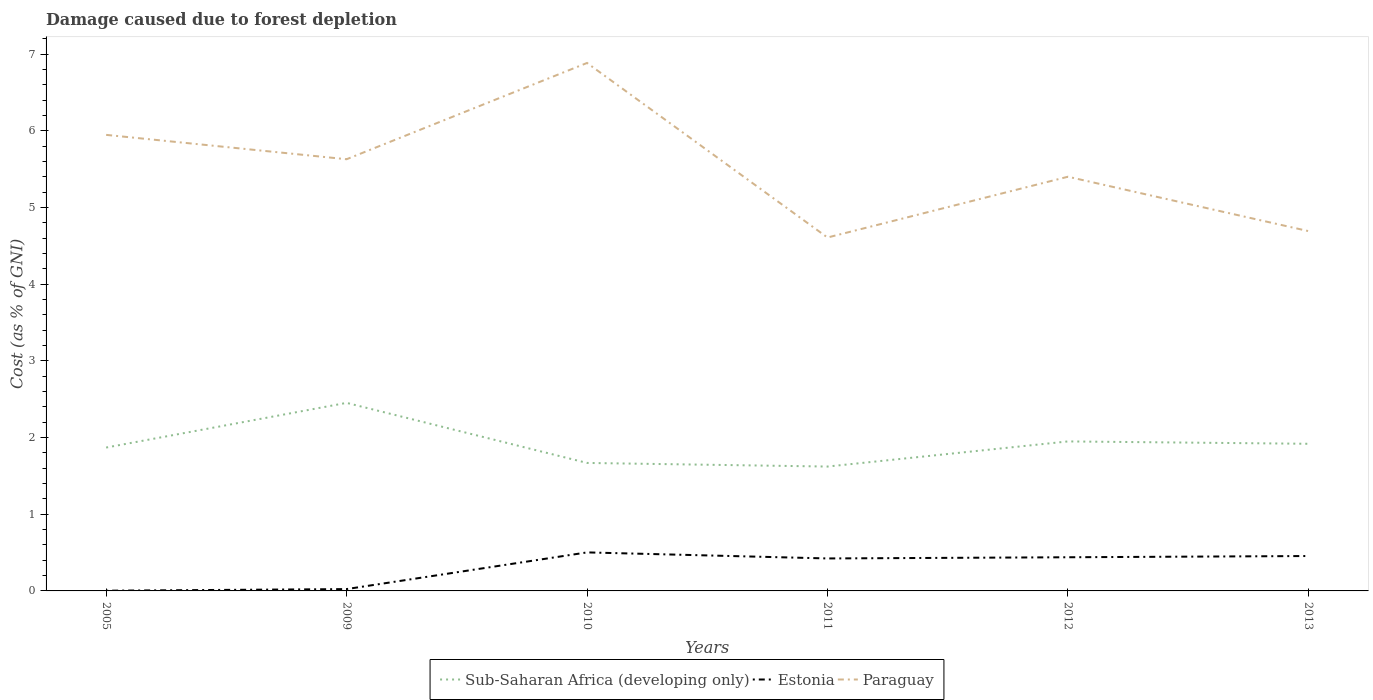How many different coloured lines are there?
Ensure brevity in your answer.  3. Does the line corresponding to Paraguay intersect with the line corresponding to Sub-Saharan Africa (developing only)?
Your response must be concise. No. Across all years, what is the maximum cost of damage caused due to forest depletion in Paraguay?
Your answer should be compact. 4.61. In which year was the cost of damage caused due to forest depletion in Sub-Saharan Africa (developing only) maximum?
Provide a short and direct response. 2011. What is the total cost of damage caused due to forest depletion in Sub-Saharan Africa (developing only) in the graph?
Your response must be concise. 0.2. What is the difference between the highest and the second highest cost of damage caused due to forest depletion in Estonia?
Your response must be concise. 0.5. What is the difference between the highest and the lowest cost of damage caused due to forest depletion in Paraguay?
Provide a short and direct response. 3. How many lines are there?
Ensure brevity in your answer.  3. Are the values on the major ticks of Y-axis written in scientific E-notation?
Make the answer very short. No. Does the graph contain any zero values?
Make the answer very short. No. How are the legend labels stacked?
Your response must be concise. Horizontal. What is the title of the graph?
Provide a succinct answer. Damage caused due to forest depletion. Does "Malta" appear as one of the legend labels in the graph?
Ensure brevity in your answer.  No. What is the label or title of the X-axis?
Your answer should be very brief. Years. What is the label or title of the Y-axis?
Your answer should be very brief. Cost (as % of GNI). What is the Cost (as % of GNI) in Sub-Saharan Africa (developing only) in 2005?
Offer a terse response. 1.87. What is the Cost (as % of GNI) in Estonia in 2005?
Offer a terse response. 0. What is the Cost (as % of GNI) of Paraguay in 2005?
Provide a short and direct response. 5.95. What is the Cost (as % of GNI) of Sub-Saharan Africa (developing only) in 2009?
Give a very brief answer. 2.45. What is the Cost (as % of GNI) in Estonia in 2009?
Ensure brevity in your answer.  0.02. What is the Cost (as % of GNI) in Paraguay in 2009?
Your answer should be very brief. 5.63. What is the Cost (as % of GNI) of Sub-Saharan Africa (developing only) in 2010?
Provide a succinct answer. 1.67. What is the Cost (as % of GNI) of Estonia in 2010?
Ensure brevity in your answer.  0.5. What is the Cost (as % of GNI) in Paraguay in 2010?
Offer a terse response. 6.88. What is the Cost (as % of GNI) of Sub-Saharan Africa (developing only) in 2011?
Your response must be concise. 1.62. What is the Cost (as % of GNI) of Estonia in 2011?
Keep it short and to the point. 0.42. What is the Cost (as % of GNI) in Paraguay in 2011?
Your answer should be very brief. 4.61. What is the Cost (as % of GNI) in Sub-Saharan Africa (developing only) in 2012?
Offer a terse response. 1.95. What is the Cost (as % of GNI) of Estonia in 2012?
Ensure brevity in your answer.  0.44. What is the Cost (as % of GNI) of Paraguay in 2012?
Make the answer very short. 5.4. What is the Cost (as % of GNI) of Sub-Saharan Africa (developing only) in 2013?
Provide a succinct answer. 1.92. What is the Cost (as % of GNI) of Estonia in 2013?
Ensure brevity in your answer.  0.46. What is the Cost (as % of GNI) of Paraguay in 2013?
Provide a short and direct response. 4.69. Across all years, what is the maximum Cost (as % of GNI) of Sub-Saharan Africa (developing only)?
Make the answer very short. 2.45. Across all years, what is the maximum Cost (as % of GNI) in Estonia?
Give a very brief answer. 0.5. Across all years, what is the maximum Cost (as % of GNI) in Paraguay?
Your answer should be very brief. 6.88. Across all years, what is the minimum Cost (as % of GNI) in Sub-Saharan Africa (developing only)?
Ensure brevity in your answer.  1.62. Across all years, what is the minimum Cost (as % of GNI) of Estonia?
Provide a succinct answer. 0. Across all years, what is the minimum Cost (as % of GNI) of Paraguay?
Make the answer very short. 4.61. What is the total Cost (as % of GNI) in Sub-Saharan Africa (developing only) in the graph?
Offer a very short reply. 11.48. What is the total Cost (as % of GNI) of Estonia in the graph?
Your response must be concise. 1.85. What is the total Cost (as % of GNI) of Paraguay in the graph?
Provide a succinct answer. 33.16. What is the difference between the Cost (as % of GNI) of Sub-Saharan Africa (developing only) in 2005 and that in 2009?
Offer a terse response. -0.58. What is the difference between the Cost (as % of GNI) in Estonia in 2005 and that in 2009?
Your answer should be compact. -0.02. What is the difference between the Cost (as % of GNI) in Paraguay in 2005 and that in 2009?
Your response must be concise. 0.32. What is the difference between the Cost (as % of GNI) of Sub-Saharan Africa (developing only) in 2005 and that in 2010?
Keep it short and to the point. 0.2. What is the difference between the Cost (as % of GNI) in Estonia in 2005 and that in 2010?
Your answer should be very brief. -0.5. What is the difference between the Cost (as % of GNI) of Paraguay in 2005 and that in 2010?
Your response must be concise. -0.94. What is the difference between the Cost (as % of GNI) in Sub-Saharan Africa (developing only) in 2005 and that in 2011?
Your answer should be very brief. 0.25. What is the difference between the Cost (as % of GNI) of Estonia in 2005 and that in 2011?
Offer a terse response. -0.42. What is the difference between the Cost (as % of GNI) in Paraguay in 2005 and that in 2011?
Your response must be concise. 1.34. What is the difference between the Cost (as % of GNI) of Sub-Saharan Africa (developing only) in 2005 and that in 2012?
Your answer should be compact. -0.08. What is the difference between the Cost (as % of GNI) in Estonia in 2005 and that in 2012?
Your answer should be compact. -0.44. What is the difference between the Cost (as % of GNI) of Paraguay in 2005 and that in 2012?
Offer a terse response. 0.55. What is the difference between the Cost (as % of GNI) in Sub-Saharan Africa (developing only) in 2005 and that in 2013?
Ensure brevity in your answer.  -0.05. What is the difference between the Cost (as % of GNI) in Estonia in 2005 and that in 2013?
Provide a short and direct response. -0.45. What is the difference between the Cost (as % of GNI) in Paraguay in 2005 and that in 2013?
Your response must be concise. 1.25. What is the difference between the Cost (as % of GNI) of Sub-Saharan Africa (developing only) in 2009 and that in 2010?
Offer a terse response. 0.78. What is the difference between the Cost (as % of GNI) in Estonia in 2009 and that in 2010?
Your answer should be compact. -0.48. What is the difference between the Cost (as % of GNI) in Paraguay in 2009 and that in 2010?
Your answer should be compact. -1.26. What is the difference between the Cost (as % of GNI) of Sub-Saharan Africa (developing only) in 2009 and that in 2011?
Your answer should be compact. 0.83. What is the difference between the Cost (as % of GNI) in Estonia in 2009 and that in 2011?
Make the answer very short. -0.4. What is the difference between the Cost (as % of GNI) in Paraguay in 2009 and that in 2011?
Ensure brevity in your answer.  1.02. What is the difference between the Cost (as % of GNI) of Sub-Saharan Africa (developing only) in 2009 and that in 2012?
Give a very brief answer. 0.5. What is the difference between the Cost (as % of GNI) of Estonia in 2009 and that in 2012?
Offer a terse response. -0.42. What is the difference between the Cost (as % of GNI) in Paraguay in 2009 and that in 2012?
Your response must be concise. 0.23. What is the difference between the Cost (as % of GNI) of Sub-Saharan Africa (developing only) in 2009 and that in 2013?
Ensure brevity in your answer.  0.53. What is the difference between the Cost (as % of GNI) in Estonia in 2009 and that in 2013?
Give a very brief answer. -0.43. What is the difference between the Cost (as % of GNI) in Paraguay in 2009 and that in 2013?
Give a very brief answer. 0.94. What is the difference between the Cost (as % of GNI) in Sub-Saharan Africa (developing only) in 2010 and that in 2011?
Your response must be concise. 0.05. What is the difference between the Cost (as % of GNI) in Estonia in 2010 and that in 2011?
Keep it short and to the point. 0.08. What is the difference between the Cost (as % of GNI) of Paraguay in 2010 and that in 2011?
Provide a short and direct response. 2.28. What is the difference between the Cost (as % of GNI) of Sub-Saharan Africa (developing only) in 2010 and that in 2012?
Keep it short and to the point. -0.28. What is the difference between the Cost (as % of GNI) in Estonia in 2010 and that in 2012?
Keep it short and to the point. 0.06. What is the difference between the Cost (as % of GNI) in Paraguay in 2010 and that in 2012?
Your answer should be very brief. 1.48. What is the difference between the Cost (as % of GNI) of Sub-Saharan Africa (developing only) in 2010 and that in 2013?
Make the answer very short. -0.25. What is the difference between the Cost (as % of GNI) in Estonia in 2010 and that in 2013?
Provide a short and direct response. 0.05. What is the difference between the Cost (as % of GNI) of Paraguay in 2010 and that in 2013?
Your answer should be compact. 2.19. What is the difference between the Cost (as % of GNI) in Sub-Saharan Africa (developing only) in 2011 and that in 2012?
Offer a very short reply. -0.33. What is the difference between the Cost (as % of GNI) of Estonia in 2011 and that in 2012?
Offer a very short reply. -0.02. What is the difference between the Cost (as % of GNI) in Paraguay in 2011 and that in 2012?
Your answer should be compact. -0.79. What is the difference between the Cost (as % of GNI) in Sub-Saharan Africa (developing only) in 2011 and that in 2013?
Provide a short and direct response. -0.3. What is the difference between the Cost (as % of GNI) of Estonia in 2011 and that in 2013?
Your response must be concise. -0.03. What is the difference between the Cost (as % of GNI) in Paraguay in 2011 and that in 2013?
Provide a short and direct response. -0.08. What is the difference between the Cost (as % of GNI) of Sub-Saharan Africa (developing only) in 2012 and that in 2013?
Offer a very short reply. 0.03. What is the difference between the Cost (as % of GNI) of Estonia in 2012 and that in 2013?
Keep it short and to the point. -0.02. What is the difference between the Cost (as % of GNI) in Paraguay in 2012 and that in 2013?
Offer a very short reply. 0.71. What is the difference between the Cost (as % of GNI) in Sub-Saharan Africa (developing only) in 2005 and the Cost (as % of GNI) in Estonia in 2009?
Your response must be concise. 1.85. What is the difference between the Cost (as % of GNI) of Sub-Saharan Africa (developing only) in 2005 and the Cost (as % of GNI) of Paraguay in 2009?
Give a very brief answer. -3.76. What is the difference between the Cost (as % of GNI) of Estonia in 2005 and the Cost (as % of GNI) of Paraguay in 2009?
Offer a terse response. -5.63. What is the difference between the Cost (as % of GNI) in Sub-Saharan Africa (developing only) in 2005 and the Cost (as % of GNI) in Estonia in 2010?
Keep it short and to the point. 1.37. What is the difference between the Cost (as % of GNI) in Sub-Saharan Africa (developing only) in 2005 and the Cost (as % of GNI) in Paraguay in 2010?
Your answer should be very brief. -5.01. What is the difference between the Cost (as % of GNI) of Estonia in 2005 and the Cost (as % of GNI) of Paraguay in 2010?
Provide a succinct answer. -6.88. What is the difference between the Cost (as % of GNI) of Sub-Saharan Africa (developing only) in 2005 and the Cost (as % of GNI) of Estonia in 2011?
Give a very brief answer. 1.45. What is the difference between the Cost (as % of GNI) of Sub-Saharan Africa (developing only) in 2005 and the Cost (as % of GNI) of Paraguay in 2011?
Offer a terse response. -2.74. What is the difference between the Cost (as % of GNI) of Estonia in 2005 and the Cost (as % of GNI) of Paraguay in 2011?
Your response must be concise. -4.61. What is the difference between the Cost (as % of GNI) of Sub-Saharan Africa (developing only) in 2005 and the Cost (as % of GNI) of Estonia in 2012?
Provide a succinct answer. 1.43. What is the difference between the Cost (as % of GNI) in Sub-Saharan Africa (developing only) in 2005 and the Cost (as % of GNI) in Paraguay in 2012?
Ensure brevity in your answer.  -3.53. What is the difference between the Cost (as % of GNI) in Estonia in 2005 and the Cost (as % of GNI) in Paraguay in 2012?
Offer a terse response. -5.4. What is the difference between the Cost (as % of GNI) of Sub-Saharan Africa (developing only) in 2005 and the Cost (as % of GNI) of Estonia in 2013?
Provide a short and direct response. 1.41. What is the difference between the Cost (as % of GNI) in Sub-Saharan Africa (developing only) in 2005 and the Cost (as % of GNI) in Paraguay in 2013?
Provide a succinct answer. -2.82. What is the difference between the Cost (as % of GNI) in Estonia in 2005 and the Cost (as % of GNI) in Paraguay in 2013?
Your response must be concise. -4.69. What is the difference between the Cost (as % of GNI) in Sub-Saharan Africa (developing only) in 2009 and the Cost (as % of GNI) in Estonia in 2010?
Your response must be concise. 1.95. What is the difference between the Cost (as % of GNI) in Sub-Saharan Africa (developing only) in 2009 and the Cost (as % of GNI) in Paraguay in 2010?
Provide a short and direct response. -4.43. What is the difference between the Cost (as % of GNI) in Estonia in 2009 and the Cost (as % of GNI) in Paraguay in 2010?
Offer a very short reply. -6.86. What is the difference between the Cost (as % of GNI) of Sub-Saharan Africa (developing only) in 2009 and the Cost (as % of GNI) of Estonia in 2011?
Give a very brief answer. 2.03. What is the difference between the Cost (as % of GNI) of Sub-Saharan Africa (developing only) in 2009 and the Cost (as % of GNI) of Paraguay in 2011?
Your answer should be compact. -2.16. What is the difference between the Cost (as % of GNI) in Estonia in 2009 and the Cost (as % of GNI) in Paraguay in 2011?
Offer a terse response. -4.58. What is the difference between the Cost (as % of GNI) of Sub-Saharan Africa (developing only) in 2009 and the Cost (as % of GNI) of Estonia in 2012?
Offer a terse response. 2.01. What is the difference between the Cost (as % of GNI) of Sub-Saharan Africa (developing only) in 2009 and the Cost (as % of GNI) of Paraguay in 2012?
Your response must be concise. -2.95. What is the difference between the Cost (as % of GNI) in Estonia in 2009 and the Cost (as % of GNI) in Paraguay in 2012?
Give a very brief answer. -5.38. What is the difference between the Cost (as % of GNI) in Sub-Saharan Africa (developing only) in 2009 and the Cost (as % of GNI) in Estonia in 2013?
Offer a very short reply. 2. What is the difference between the Cost (as % of GNI) of Sub-Saharan Africa (developing only) in 2009 and the Cost (as % of GNI) of Paraguay in 2013?
Your answer should be compact. -2.24. What is the difference between the Cost (as % of GNI) in Estonia in 2009 and the Cost (as % of GNI) in Paraguay in 2013?
Provide a succinct answer. -4.67. What is the difference between the Cost (as % of GNI) of Sub-Saharan Africa (developing only) in 2010 and the Cost (as % of GNI) of Estonia in 2011?
Provide a succinct answer. 1.25. What is the difference between the Cost (as % of GNI) in Sub-Saharan Africa (developing only) in 2010 and the Cost (as % of GNI) in Paraguay in 2011?
Make the answer very short. -2.94. What is the difference between the Cost (as % of GNI) of Estonia in 2010 and the Cost (as % of GNI) of Paraguay in 2011?
Provide a short and direct response. -4.11. What is the difference between the Cost (as % of GNI) of Sub-Saharan Africa (developing only) in 2010 and the Cost (as % of GNI) of Estonia in 2012?
Provide a succinct answer. 1.23. What is the difference between the Cost (as % of GNI) in Sub-Saharan Africa (developing only) in 2010 and the Cost (as % of GNI) in Paraguay in 2012?
Provide a short and direct response. -3.73. What is the difference between the Cost (as % of GNI) in Estonia in 2010 and the Cost (as % of GNI) in Paraguay in 2012?
Make the answer very short. -4.9. What is the difference between the Cost (as % of GNI) of Sub-Saharan Africa (developing only) in 2010 and the Cost (as % of GNI) of Estonia in 2013?
Make the answer very short. 1.21. What is the difference between the Cost (as % of GNI) of Sub-Saharan Africa (developing only) in 2010 and the Cost (as % of GNI) of Paraguay in 2013?
Keep it short and to the point. -3.02. What is the difference between the Cost (as % of GNI) in Estonia in 2010 and the Cost (as % of GNI) in Paraguay in 2013?
Your answer should be very brief. -4.19. What is the difference between the Cost (as % of GNI) of Sub-Saharan Africa (developing only) in 2011 and the Cost (as % of GNI) of Estonia in 2012?
Keep it short and to the point. 1.18. What is the difference between the Cost (as % of GNI) of Sub-Saharan Africa (developing only) in 2011 and the Cost (as % of GNI) of Paraguay in 2012?
Offer a very short reply. -3.78. What is the difference between the Cost (as % of GNI) of Estonia in 2011 and the Cost (as % of GNI) of Paraguay in 2012?
Provide a succinct answer. -4.98. What is the difference between the Cost (as % of GNI) of Sub-Saharan Africa (developing only) in 2011 and the Cost (as % of GNI) of Estonia in 2013?
Give a very brief answer. 1.17. What is the difference between the Cost (as % of GNI) of Sub-Saharan Africa (developing only) in 2011 and the Cost (as % of GNI) of Paraguay in 2013?
Your answer should be compact. -3.07. What is the difference between the Cost (as % of GNI) of Estonia in 2011 and the Cost (as % of GNI) of Paraguay in 2013?
Provide a succinct answer. -4.27. What is the difference between the Cost (as % of GNI) in Sub-Saharan Africa (developing only) in 2012 and the Cost (as % of GNI) in Estonia in 2013?
Make the answer very short. 1.49. What is the difference between the Cost (as % of GNI) in Sub-Saharan Africa (developing only) in 2012 and the Cost (as % of GNI) in Paraguay in 2013?
Ensure brevity in your answer.  -2.74. What is the difference between the Cost (as % of GNI) in Estonia in 2012 and the Cost (as % of GNI) in Paraguay in 2013?
Offer a terse response. -4.25. What is the average Cost (as % of GNI) of Sub-Saharan Africa (developing only) per year?
Your answer should be compact. 1.91. What is the average Cost (as % of GNI) of Estonia per year?
Ensure brevity in your answer.  0.31. What is the average Cost (as % of GNI) in Paraguay per year?
Your response must be concise. 5.53. In the year 2005, what is the difference between the Cost (as % of GNI) of Sub-Saharan Africa (developing only) and Cost (as % of GNI) of Estonia?
Ensure brevity in your answer.  1.87. In the year 2005, what is the difference between the Cost (as % of GNI) in Sub-Saharan Africa (developing only) and Cost (as % of GNI) in Paraguay?
Provide a short and direct response. -4.08. In the year 2005, what is the difference between the Cost (as % of GNI) of Estonia and Cost (as % of GNI) of Paraguay?
Offer a very short reply. -5.94. In the year 2009, what is the difference between the Cost (as % of GNI) in Sub-Saharan Africa (developing only) and Cost (as % of GNI) in Estonia?
Your answer should be very brief. 2.43. In the year 2009, what is the difference between the Cost (as % of GNI) of Sub-Saharan Africa (developing only) and Cost (as % of GNI) of Paraguay?
Your response must be concise. -3.18. In the year 2009, what is the difference between the Cost (as % of GNI) in Estonia and Cost (as % of GNI) in Paraguay?
Your answer should be compact. -5.61. In the year 2010, what is the difference between the Cost (as % of GNI) of Sub-Saharan Africa (developing only) and Cost (as % of GNI) of Estonia?
Provide a short and direct response. 1.17. In the year 2010, what is the difference between the Cost (as % of GNI) in Sub-Saharan Africa (developing only) and Cost (as % of GNI) in Paraguay?
Offer a terse response. -5.22. In the year 2010, what is the difference between the Cost (as % of GNI) of Estonia and Cost (as % of GNI) of Paraguay?
Your answer should be compact. -6.38. In the year 2011, what is the difference between the Cost (as % of GNI) of Sub-Saharan Africa (developing only) and Cost (as % of GNI) of Estonia?
Your answer should be very brief. 1.2. In the year 2011, what is the difference between the Cost (as % of GNI) in Sub-Saharan Africa (developing only) and Cost (as % of GNI) in Paraguay?
Make the answer very short. -2.99. In the year 2011, what is the difference between the Cost (as % of GNI) in Estonia and Cost (as % of GNI) in Paraguay?
Offer a terse response. -4.18. In the year 2012, what is the difference between the Cost (as % of GNI) of Sub-Saharan Africa (developing only) and Cost (as % of GNI) of Estonia?
Ensure brevity in your answer.  1.51. In the year 2012, what is the difference between the Cost (as % of GNI) in Sub-Saharan Africa (developing only) and Cost (as % of GNI) in Paraguay?
Offer a very short reply. -3.45. In the year 2012, what is the difference between the Cost (as % of GNI) in Estonia and Cost (as % of GNI) in Paraguay?
Give a very brief answer. -4.96. In the year 2013, what is the difference between the Cost (as % of GNI) in Sub-Saharan Africa (developing only) and Cost (as % of GNI) in Estonia?
Offer a very short reply. 1.46. In the year 2013, what is the difference between the Cost (as % of GNI) in Sub-Saharan Africa (developing only) and Cost (as % of GNI) in Paraguay?
Your answer should be very brief. -2.77. In the year 2013, what is the difference between the Cost (as % of GNI) of Estonia and Cost (as % of GNI) of Paraguay?
Provide a short and direct response. -4.24. What is the ratio of the Cost (as % of GNI) of Sub-Saharan Africa (developing only) in 2005 to that in 2009?
Your answer should be very brief. 0.76. What is the ratio of the Cost (as % of GNI) in Estonia in 2005 to that in 2009?
Your answer should be compact. 0.12. What is the ratio of the Cost (as % of GNI) in Paraguay in 2005 to that in 2009?
Provide a succinct answer. 1.06. What is the ratio of the Cost (as % of GNI) in Sub-Saharan Africa (developing only) in 2005 to that in 2010?
Your answer should be compact. 1.12. What is the ratio of the Cost (as % of GNI) in Estonia in 2005 to that in 2010?
Provide a succinct answer. 0.01. What is the ratio of the Cost (as % of GNI) of Paraguay in 2005 to that in 2010?
Provide a short and direct response. 0.86. What is the ratio of the Cost (as % of GNI) of Sub-Saharan Africa (developing only) in 2005 to that in 2011?
Keep it short and to the point. 1.15. What is the ratio of the Cost (as % of GNI) of Estonia in 2005 to that in 2011?
Ensure brevity in your answer.  0.01. What is the ratio of the Cost (as % of GNI) in Paraguay in 2005 to that in 2011?
Keep it short and to the point. 1.29. What is the ratio of the Cost (as % of GNI) of Sub-Saharan Africa (developing only) in 2005 to that in 2012?
Your response must be concise. 0.96. What is the ratio of the Cost (as % of GNI) in Estonia in 2005 to that in 2012?
Make the answer very short. 0.01. What is the ratio of the Cost (as % of GNI) of Paraguay in 2005 to that in 2012?
Ensure brevity in your answer.  1.1. What is the ratio of the Cost (as % of GNI) of Sub-Saharan Africa (developing only) in 2005 to that in 2013?
Give a very brief answer. 0.97. What is the ratio of the Cost (as % of GNI) of Estonia in 2005 to that in 2013?
Make the answer very short. 0.01. What is the ratio of the Cost (as % of GNI) of Paraguay in 2005 to that in 2013?
Provide a short and direct response. 1.27. What is the ratio of the Cost (as % of GNI) in Sub-Saharan Africa (developing only) in 2009 to that in 2010?
Keep it short and to the point. 1.47. What is the ratio of the Cost (as % of GNI) in Estonia in 2009 to that in 2010?
Offer a very short reply. 0.05. What is the ratio of the Cost (as % of GNI) of Paraguay in 2009 to that in 2010?
Ensure brevity in your answer.  0.82. What is the ratio of the Cost (as % of GNI) of Sub-Saharan Africa (developing only) in 2009 to that in 2011?
Keep it short and to the point. 1.51. What is the ratio of the Cost (as % of GNI) of Estonia in 2009 to that in 2011?
Your answer should be compact. 0.06. What is the ratio of the Cost (as % of GNI) of Paraguay in 2009 to that in 2011?
Keep it short and to the point. 1.22. What is the ratio of the Cost (as % of GNI) in Sub-Saharan Africa (developing only) in 2009 to that in 2012?
Your answer should be very brief. 1.26. What is the ratio of the Cost (as % of GNI) in Estonia in 2009 to that in 2012?
Your answer should be compact. 0.05. What is the ratio of the Cost (as % of GNI) of Paraguay in 2009 to that in 2012?
Offer a very short reply. 1.04. What is the ratio of the Cost (as % of GNI) in Sub-Saharan Africa (developing only) in 2009 to that in 2013?
Offer a very short reply. 1.28. What is the ratio of the Cost (as % of GNI) in Estonia in 2009 to that in 2013?
Your answer should be very brief. 0.05. What is the ratio of the Cost (as % of GNI) in Paraguay in 2009 to that in 2013?
Your answer should be very brief. 1.2. What is the ratio of the Cost (as % of GNI) of Sub-Saharan Africa (developing only) in 2010 to that in 2011?
Ensure brevity in your answer.  1.03. What is the ratio of the Cost (as % of GNI) in Estonia in 2010 to that in 2011?
Provide a succinct answer. 1.19. What is the ratio of the Cost (as % of GNI) of Paraguay in 2010 to that in 2011?
Provide a succinct answer. 1.49. What is the ratio of the Cost (as % of GNI) of Sub-Saharan Africa (developing only) in 2010 to that in 2012?
Give a very brief answer. 0.86. What is the ratio of the Cost (as % of GNI) in Estonia in 2010 to that in 2012?
Your answer should be compact. 1.14. What is the ratio of the Cost (as % of GNI) in Paraguay in 2010 to that in 2012?
Your response must be concise. 1.27. What is the ratio of the Cost (as % of GNI) of Sub-Saharan Africa (developing only) in 2010 to that in 2013?
Ensure brevity in your answer.  0.87. What is the ratio of the Cost (as % of GNI) in Estonia in 2010 to that in 2013?
Keep it short and to the point. 1.1. What is the ratio of the Cost (as % of GNI) in Paraguay in 2010 to that in 2013?
Your response must be concise. 1.47. What is the ratio of the Cost (as % of GNI) of Sub-Saharan Africa (developing only) in 2011 to that in 2012?
Provide a short and direct response. 0.83. What is the ratio of the Cost (as % of GNI) of Estonia in 2011 to that in 2012?
Provide a succinct answer. 0.96. What is the ratio of the Cost (as % of GNI) in Paraguay in 2011 to that in 2012?
Ensure brevity in your answer.  0.85. What is the ratio of the Cost (as % of GNI) in Sub-Saharan Africa (developing only) in 2011 to that in 2013?
Your answer should be compact. 0.85. What is the ratio of the Cost (as % of GNI) of Estonia in 2011 to that in 2013?
Make the answer very short. 0.93. What is the ratio of the Cost (as % of GNI) in Paraguay in 2011 to that in 2013?
Your response must be concise. 0.98. What is the ratio of the Cost (as % of GNI) in Sub-Saharan Africa (developing only) in 2012 to that in 2013?
Keep it short and to the point. 1.02. What is the ratio of the Cost (as % of GNI) of Estonia in 2012 to that in 2013?
Your answer should be compact. 0.96. What is the ratio of the Cost (as % of GNI) of Paraguay in 2012 to that in 2013?
Offer a terse response. 1.15. What is the difference between the highest and the second highest Cost (as % of GNI) in Sub-Saharan Africa (developing only)?
Give a very brief answer. 0.5. What is the difference between the highest and the second highest Cost (as % of GNI) in Estonia?
Your answer should be very brief. 0.05. What is the difference between the highest and the second highest Cost (as % of GNI) of Paraguay?
Offer a terse response. 0.94. What is the difference between the highest and the lowest Cost (as % of GNI) of Sub-Saharan Africa (developing only)?
Offer a very short reply. 0.83. What is the difference between the highest and the lowest Cost (as % of GNI) in Estonia?
Keep it short and to the point. 0.5. What is the difference between the highest and the lowest Cost (as % of GNI) in Paraguay?
Keep it short and to the point. 2.28. 